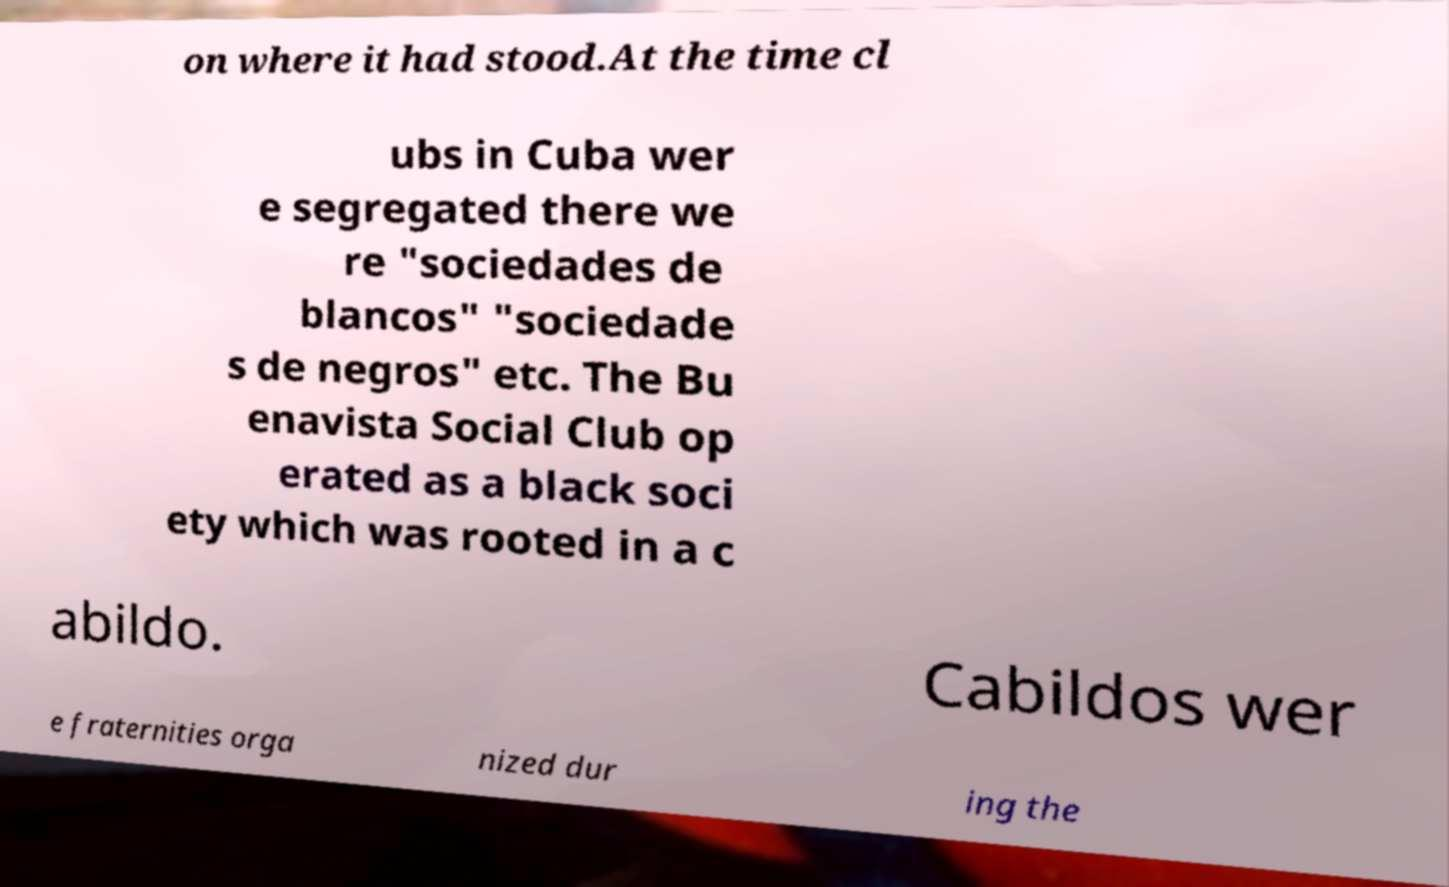Could you extract and type out the text from this image? on where it had stood.At the time cl ubs in Cuba wer e segregated there we re "sociedades de blancos" "sociedade s de negros" etc. The Bu enavista Social Club op erated as a black soci ety which was rooted in a c abildo. Cabildos wer e fraternities orga nized dur ing the 